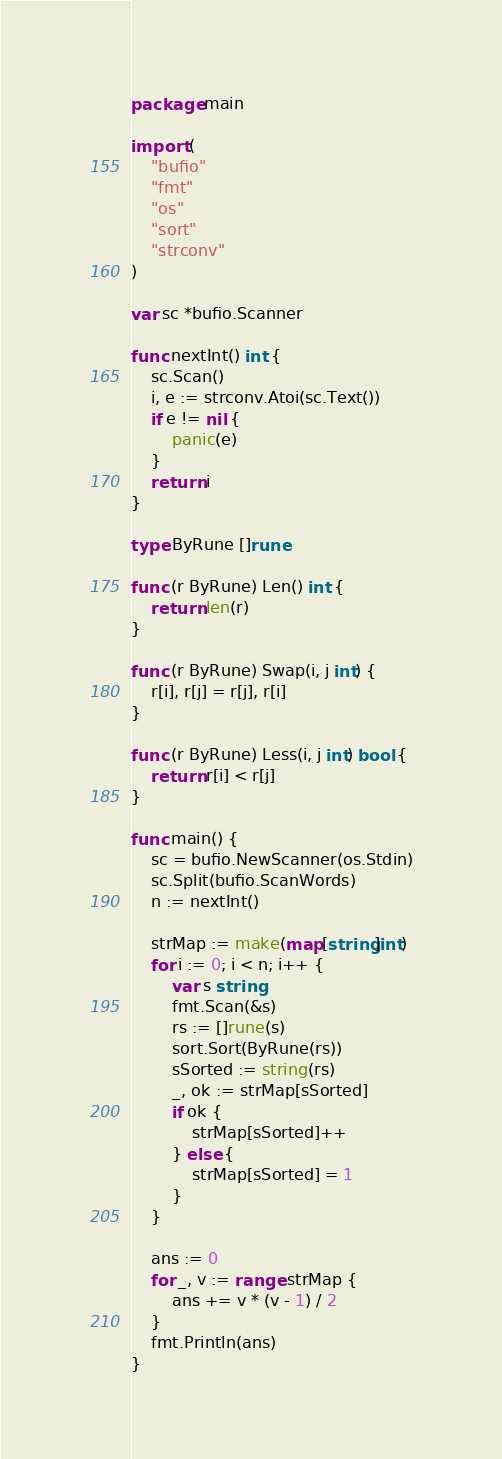Convert code to text. <code><loc_0><loc_0><loc_500><loc_500><_Go_>package main

import (
	"bufio"
	"fmt"
	"os"
	"sort"
	"strconv"
)

var sc *bufio.Scanner

func nextInt() int {
	sc.Scan()
	i, e := strconv.Atoi(sc.Text())
	if e != nil {
		panic(e)
	}
	return i
}

type ByRune []rune

func (r ByRune) Len() int {
	return len(r)
}

func (r ByRune) Swap(i, j int) {
	r[i], r[j] = r[j], r[i]
}

func (r ByRune) Less(i, j int) bool {
	return r[i] < r[j]
}

func main() {
	sc = bufio.NewScanner(os.Stdin)
	sc.Split(bufio.ScanWords)
	n := nextInt()

	strMap := make(map[string]int)
	for i := 0; i < n; i++ {
		var s string
		fmt.Scan(&s)
		rs := []rune(s)
		sort.Sort(ByRune(rs))
		sSorted := string(rs)
		_, ok := strMap[sSorted]
		if ok {
			strMap[sSorted]++
		} else {
			strMap[sSorted] = 1
		}
	}

	ans := 0
	for _, v := range strMap {
		ans += v * (v - 1) / 2
	}
	fmt.Println(ans)
}
</code> 